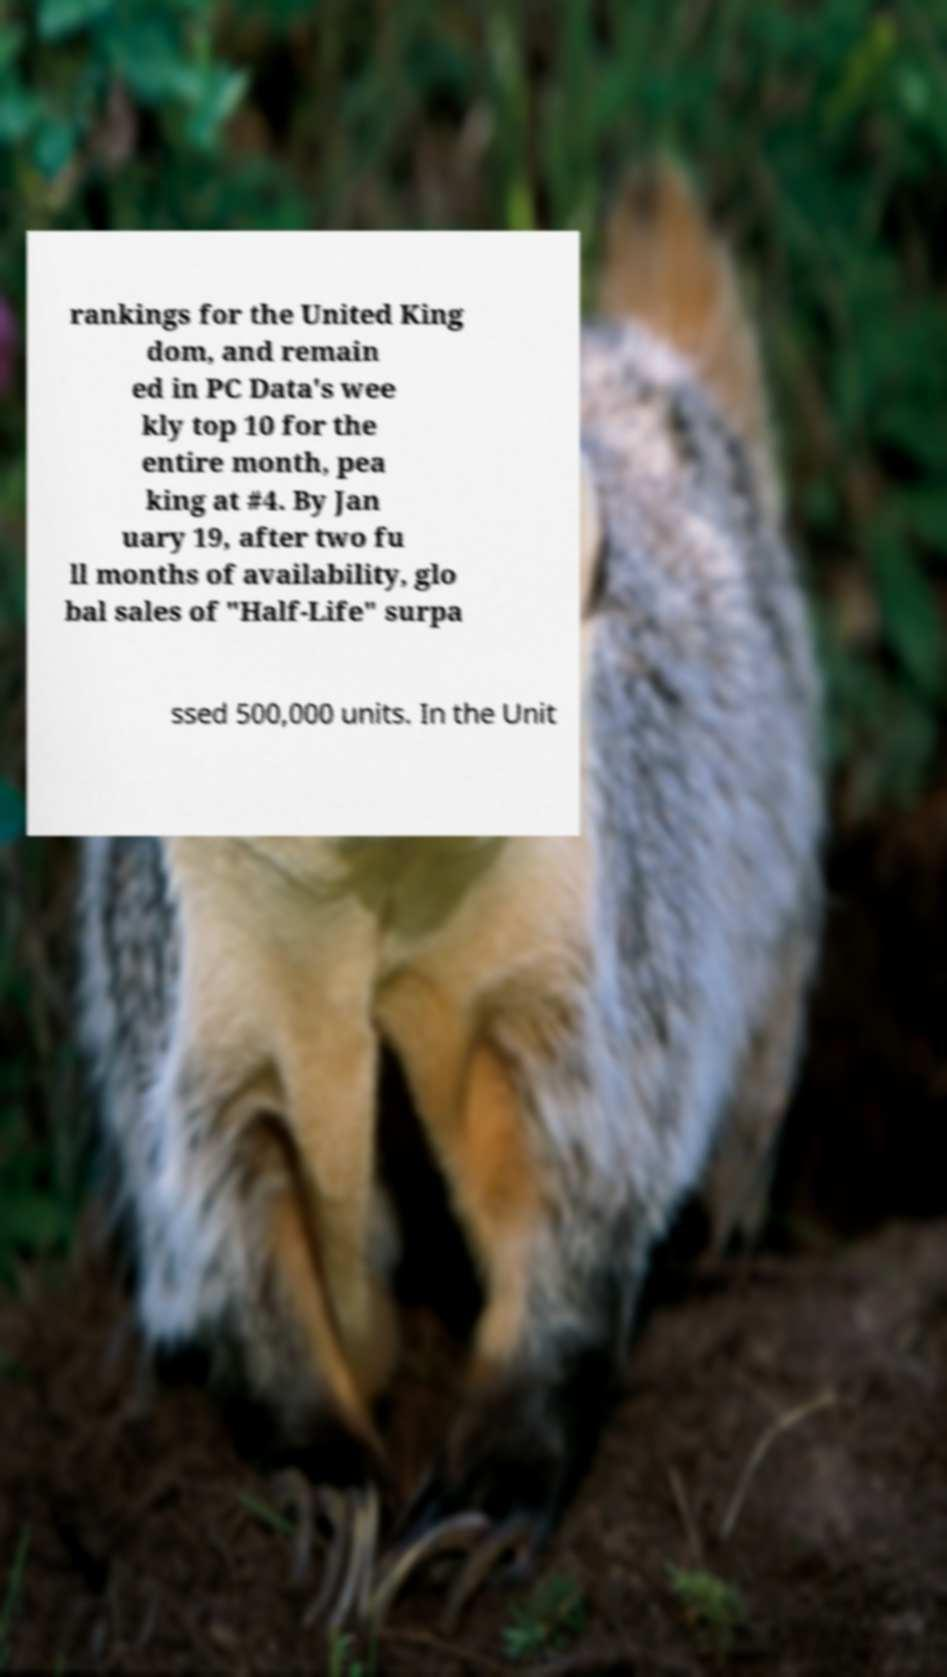For documentation purposes, I need the text within this image transcribed. Could you provide that? rankings for the United King dom, and remain ed in PC Data's wee kly top 10 for the entire month, pea king at #4. By Jan uary 19, after two fu ll months of availability, glo bal sales of "Half-Life" surpa ssed 500,000 units. In the Unit 